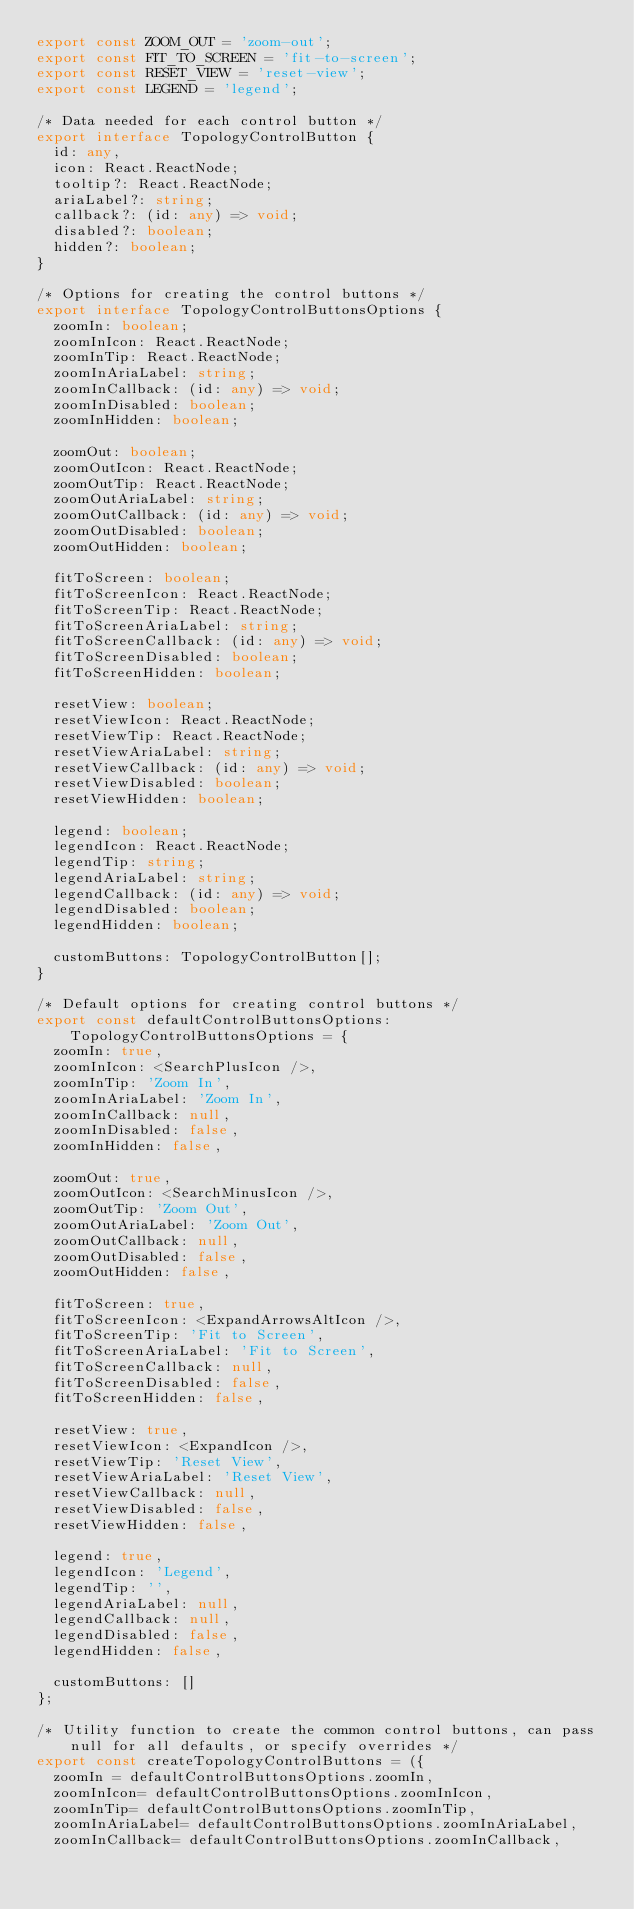Convert code to text. <code><loc_0><loc_0><loc_500><loc_500><_TypeScript_>export const ZOOM_OUT = 'zoom-out';
export const FIT_TO_SCREEN = 'fit-to-screen';
export const RESET_VIEW = 'reset-view';
export const LEGEND = 'legend';

/* Data needed for each control button */
export interface TopologyControlButton {
  id: any,
  icon: React.ReactNode;
  tooltip?: React.ReactNode;
  ariaLabel?: string;
  callback?: (id: any) => void;
  disabled?: boolean;
  hidden?: boolean;
}

/* Options for creating the control buttons */
export interface TopologyControlButtonsOptions {
  zoomIn: boolean;
  zoomInIcon: React.ReactNode;
  zoomInTip: React.ReactNode;
  zoomInAriaLabel: string;
  zoomInCallback: (id: any) => void;
  zoomInDisabled: boolean;
  zoomInHidden: boolean;

  zoomOut: boolean;
  zoomOutIcon: React.ReactNode;
  zoomOutTip: React.ReactNode;
  zoomOutAriaLabel: string;
  zoomOutCallback: (id: any) => void;
  zoomOutDisabled: boolean;
  zoomOutHidden: boolean;

  fitToScreen: boolean;
  fitToScreenIcon: React.ReactNode;
  fitToScreenTip: React.ReactNode;
  fitToScreenAriaLabel: string;
  fitToScreenCallback: (id: any) => void;
  fitToScreenDisabled: boolean;
  fitToScreenHidden: boolean;

  resetView: boolean;
  resetViewIcon: React.ReactNode;
  resetViewTip: React.ReactNode;
  resetViewAriaLabel: string;
  resetViewCallback: (id: any) => void;
  resetViewDisabled: boolean;
  resetViewHidden: boolean;

  legend: boolean;
  legendIcon: React.ReactNode;
  legendTip: string;
  legendAriaLabel: string;
  legendCallback: (id: any) => void;
  legendDisabled: boolean;
  legendHidden: boolean;

  customButtons: TopologyControlButton[];
}

/* Default options for creating control buttons */
export const defaultControlButtonsOptions: TopologyControlButtonsOptions = {
  zoomIn: true,
  zoomInIcon: <SearchPlusIcon />,
  zoomInTip: 'Zoom In',
  zoomInAriaLabel: 'Zoom In',
  zoomInCallback: null,
  zoomInDisabled: false,
  zoomInHidden: false,

  zoomOut: true,
  zoomOutIcon: <SearchMinusIcon />,
  zoomOutTip: 'Zoom Out',
  zoomOutAriaLabel: 'Zoom Out',
  zoomOutCallback: null,
  zoomOutDisabled: false,
  zoomOutHidden: false,

  fitToScreen: true,
  fitToScreenIcon: <ExpandArrowsAltIcon />,
  fitToScreenTip: 'Fit to Screen',
  fitToScreenAriaLabel: 'Fit to Screen',
  fitToScreenCallback: null,
  fitToScreenDisabled: false,
  fitToScreenHidden: false,

  resetView: true,
  resetViewIcon: <ExpandIcon />,
  resetViewTip: 'Reset View',
  resetViewAriaLabel: 'Reset View',
  resetViewCallback: null,
  resetViewDisabled: false,
  resetViewHidden: false,

  legend: true,
  legendIcon: 'Legend',
  legendTip: '',
  legendAriaLabel: null,
  legendCallback: null,
  legendDisabled: false,
  legendHidden: false,

  customButtons: []
};

/* Utility function to create the common control buttons, can pass null for all defaults, or specify overrides */
export const createTopologyControlButtons = ({
  zoomIn = defaultControlButtonsOptions.zoomIn,
  zoomInIcon= defaultControlButtonsOptions.zoomInIcon,
  zoomInTip= defaultControlButtonsOptions.zoomInTip,
  zoomInAriaLabel= defaultControlButtonsOptions.zoomInAriaLabel,
  zoomInCallback= defaultControlButtonsOptions.zoomInCallback,</code> 